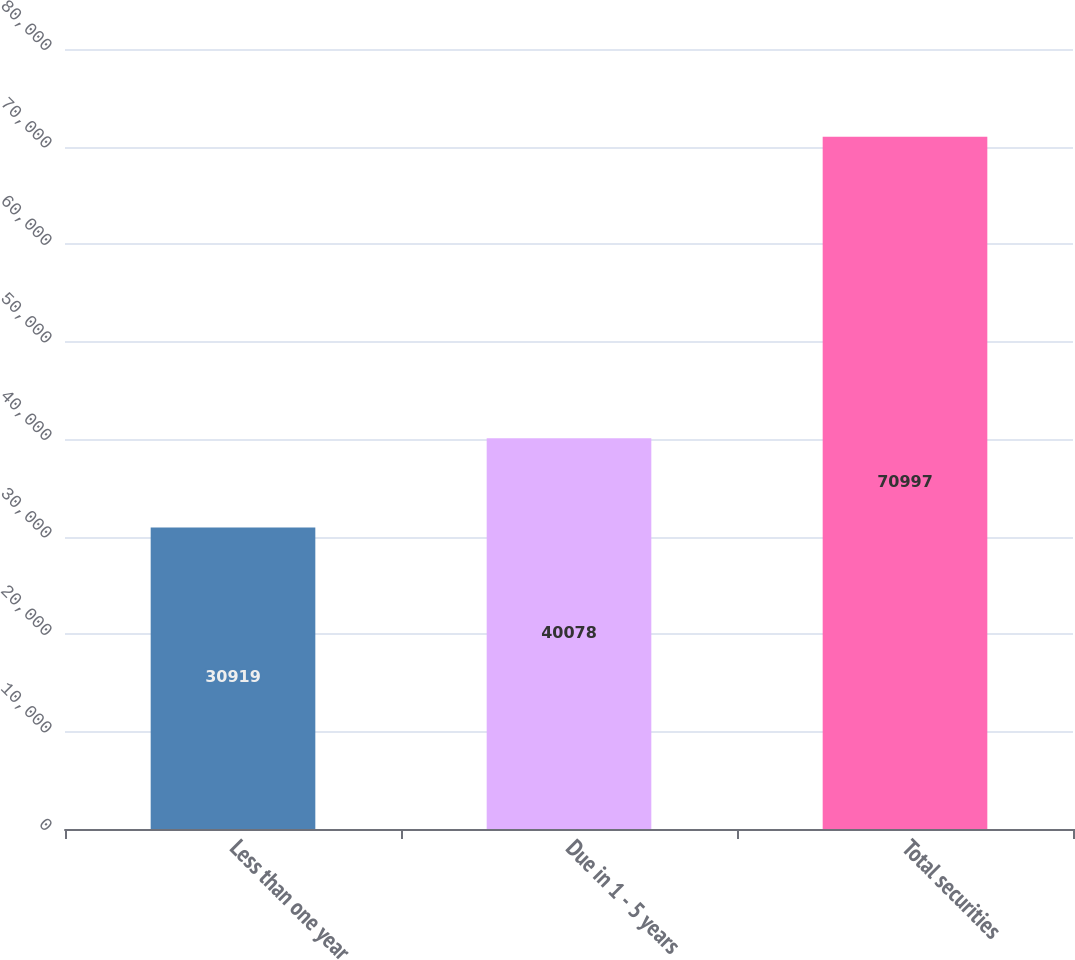Convert chart. <chart><loc_0><loc_0><loc_500><loc_500><bar_chart><fcel>Less than one year<fcel>Due in 1 - 5 years<fcel>Total securities<nl><fcel>30919<fcel>40078<fcel>70997<nl></chart> 